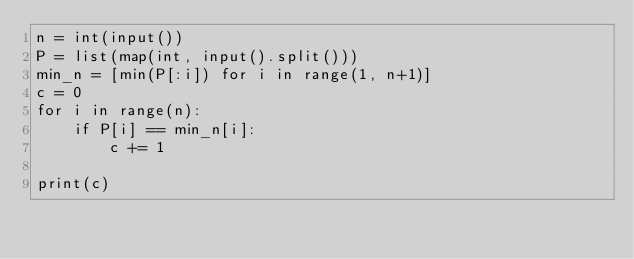<code> <loc_0><loc_0><loc_500><loc_500><_Python_>n = int(input())
P = list(map(int, input().split()))
min_n = [min(P[:i]) for i in range(1, n+1)]
c = 0
for i in range(n):
    if P[i] == min_n[i]:
        c += 1
        
print(c)</code> 